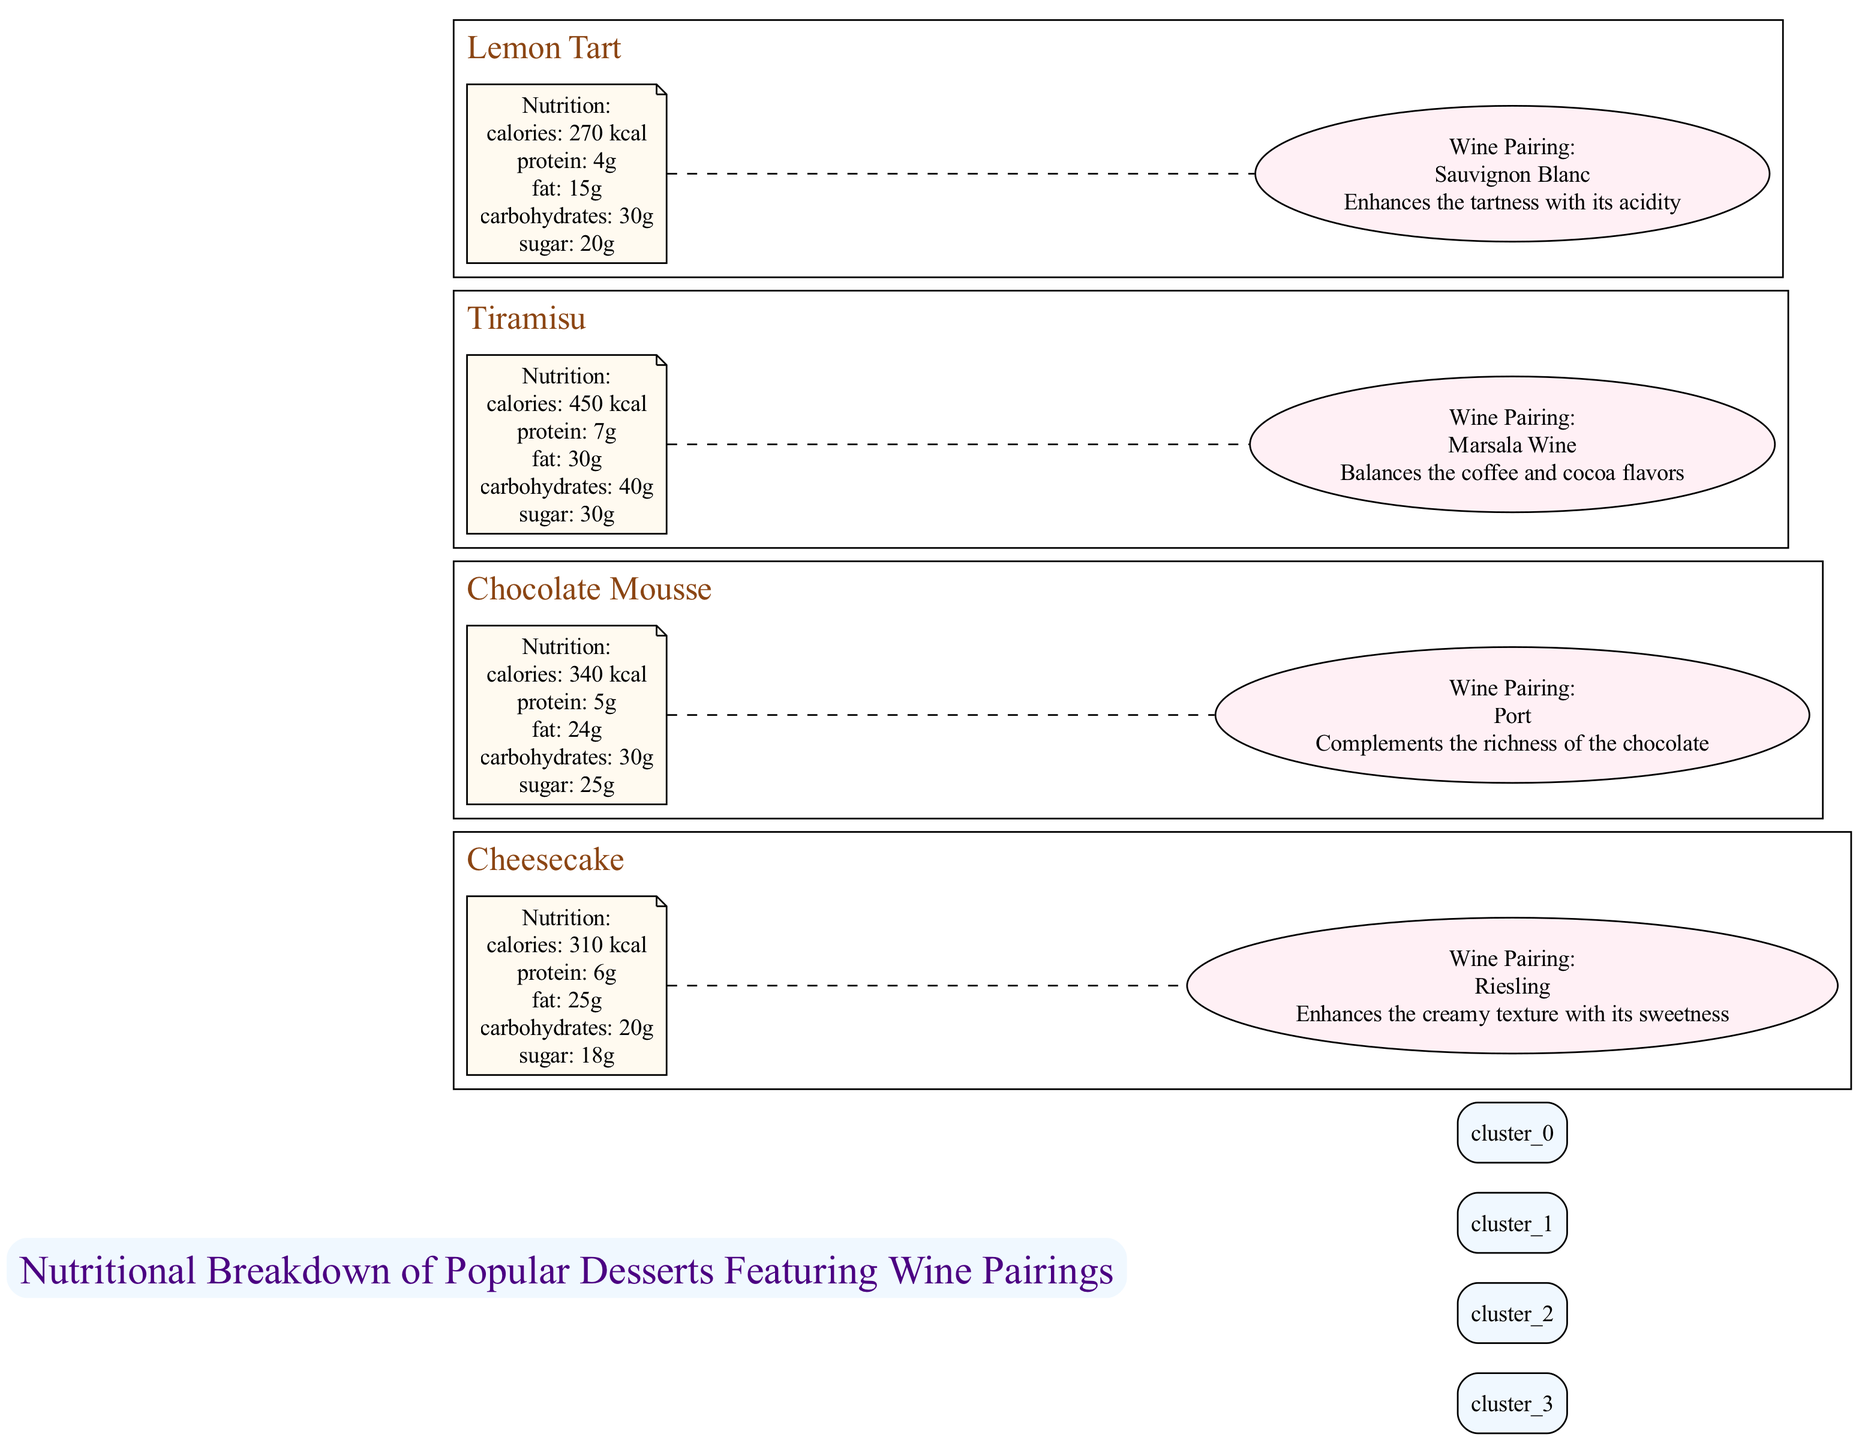What is the calorie count of Cheesecake? The calorie count is directly provided in the nutrition information for Cheesecake. It states "calories: 310 kcal."
Answer: 310 kcal Which wine pairs with Chocolate Mousse? The wine pairing information for Chocolate Mousse explicitly states the wine type as "Port."
Answer: Port What is the fat content in Tiramisu? Tiramisu's nutrition section lists "fat: 30g," indicating the amount of fat in the dessert.
Answer: 30g How many desserts are featured in the diagram? The diagram includes four sections, each representing a different dessert: Cheesecake, Chocolate Mousse, Tiramisu, and Lemon Tart.
Answer: 4 Which dessert has the highest sugar content? By comparing the sugar content in the nutrition sections, Tiramisu has 30g of sugar, which is the highest among all displayed desserts.
Answer: Tiramisu What is the relationship between Lemon Tart and Sauvignon Blanc? The diagram shows a dashed edge connecting the nutrition information of Lemon Tart to its wine pairing, indicating that Sauvignon Blanc is used to complement the dessert's flavors.
Answer: Sauvignon Blanc Which dessert has the least calories? Upon checking the calorie values provided, Lemon Tart has the lowest at 270 kcal, whereas Cheesecake, Chocolate Mousse, and Tiramisu have higher calorie counts.
Answer: 270 kcal What enhances the creamy texture in Cheesecake? The diagram specifies that Riesling, paired with Cheesecake, enhances the dessert's creamy texture with its sweetness.
Answer: Riesling What is the carbohydrate content for Chocolate Mousse? The nutrition section for Chocolate Mousse indicates "carbohydrates: 30g," which directly provides the carbohydrate content.
Answer: 30g 